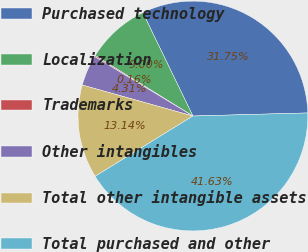Convert chart to OTSL. <chart><loc_0><loc_0><loc_500><loc_500><pie_chart><fcel>Purchased technology<fcel>Localization<fcel>Trademarks<fcel>Other intangibles<fcel>Total other intangible assets<fcel>Total purchased and other<nl><fcel>31.75%<fcel>9.0%<fcel>0.16%<fcel>4.31%<fcel>13.14%<fcel>41.63%<nl></chart> 